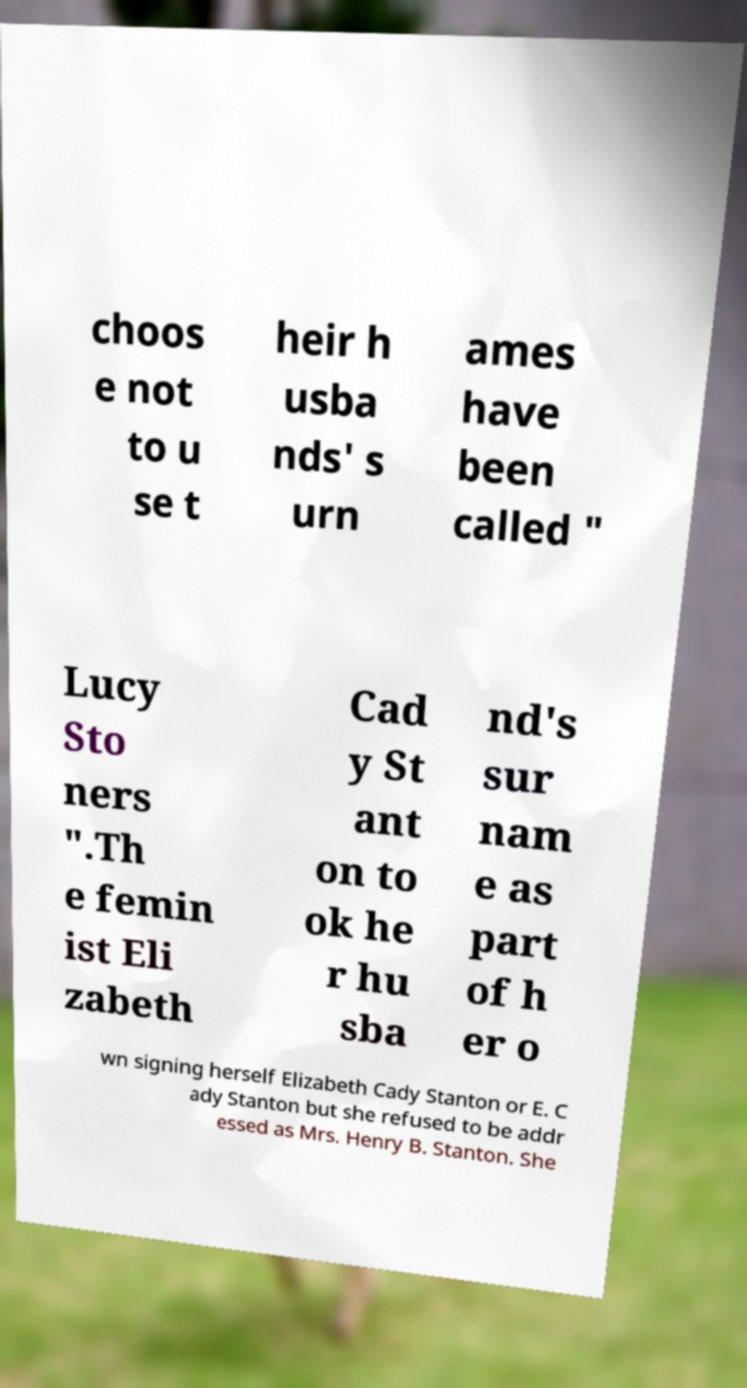Can you read and provide the text displayed in the image?This photo seems to have some interesting text. Can you extract and type it out for me? choos e not to u se t heir h usba nds' s urn ames have been called " Lucy Sto ners ".Th e femin ist Eli zabeth Cad y St ant on to ok he r hu sba nd's sur nam e as part of h er o wn signing herself Elizabeth Cady Stanton or E. C ady Stanton but she refused to be addr essed as Mrs. Henry B. Stanton. She 